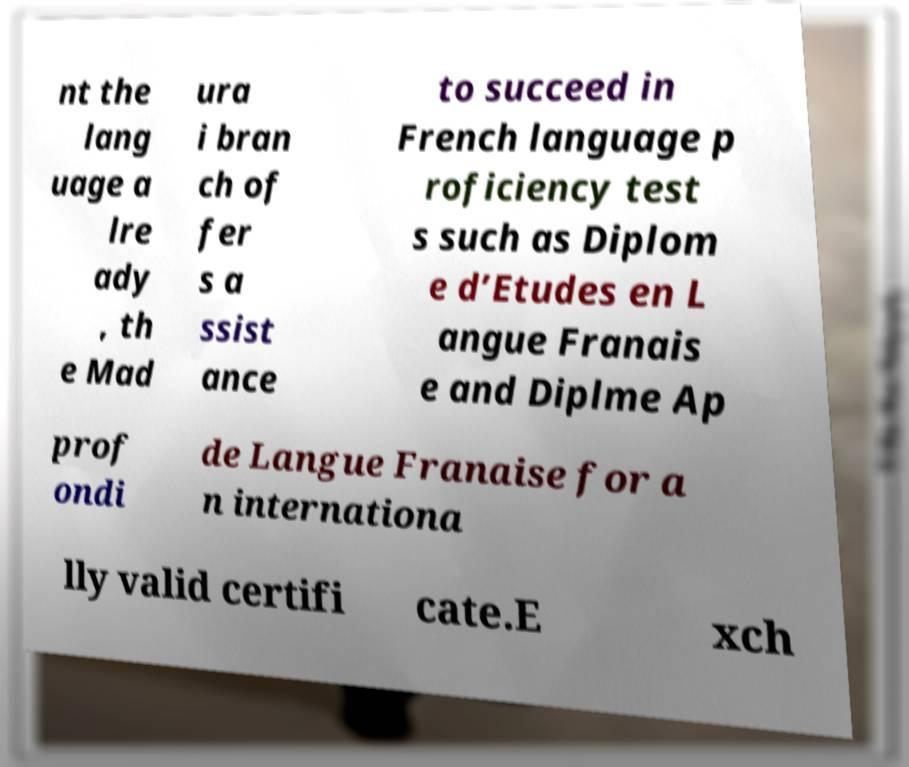Please read and relay the text visible in this image. What does it say? nt the lang uage a lre ady , th e Mad ura i bran ch of fer s a ssist ance to succeed in French language p roficiency test s such as Diplom e d’Etudes en L angue Franais e and Diplme Ap prof ondi de Langue Franaise for a n internationa lly valid certifi cate.E xch 